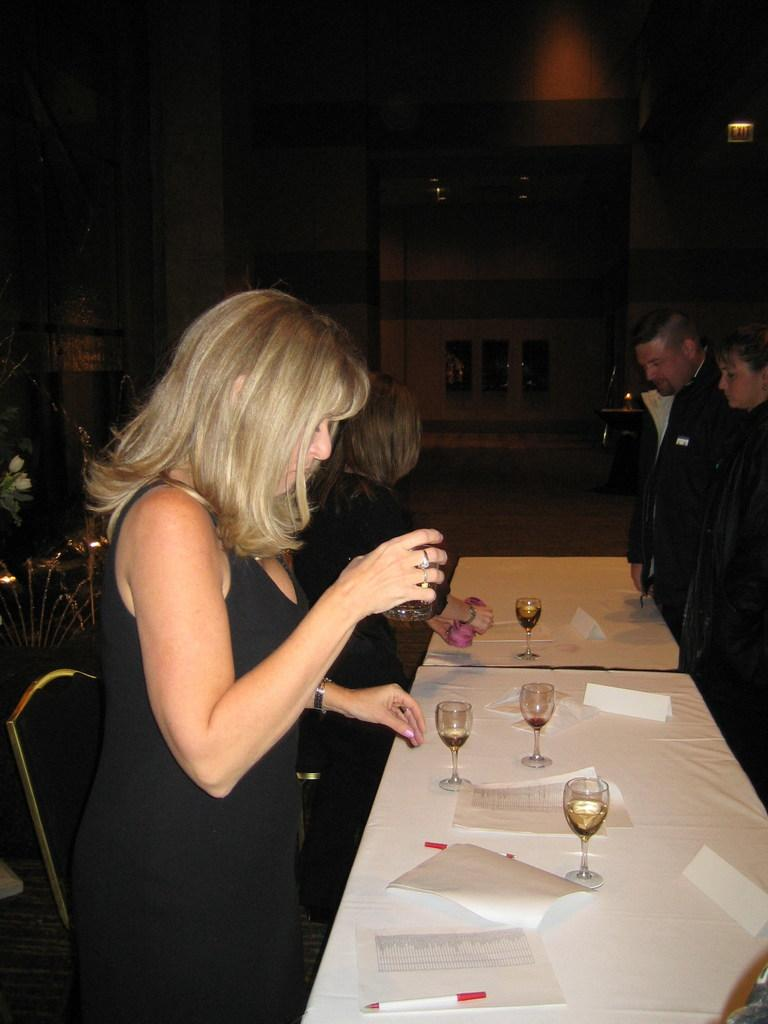What is happening in the image involving the people and the table? There are people standing around a table in the image. What items can be seen on the table? There are glasses, papers, and a pen on the table. What is visible in the background of the image? There is a wall visible in the background of the image. What objects are present around the people and the table? There are objects present around the people and the table, but their specific details are not mentioned in the provided facts. What type of meal is being served on the table in the image? There is no meal present on the table in the image; only glasses, papers, and a pen are visible. How many beds are visible in the image? There are no beds present in the image. 